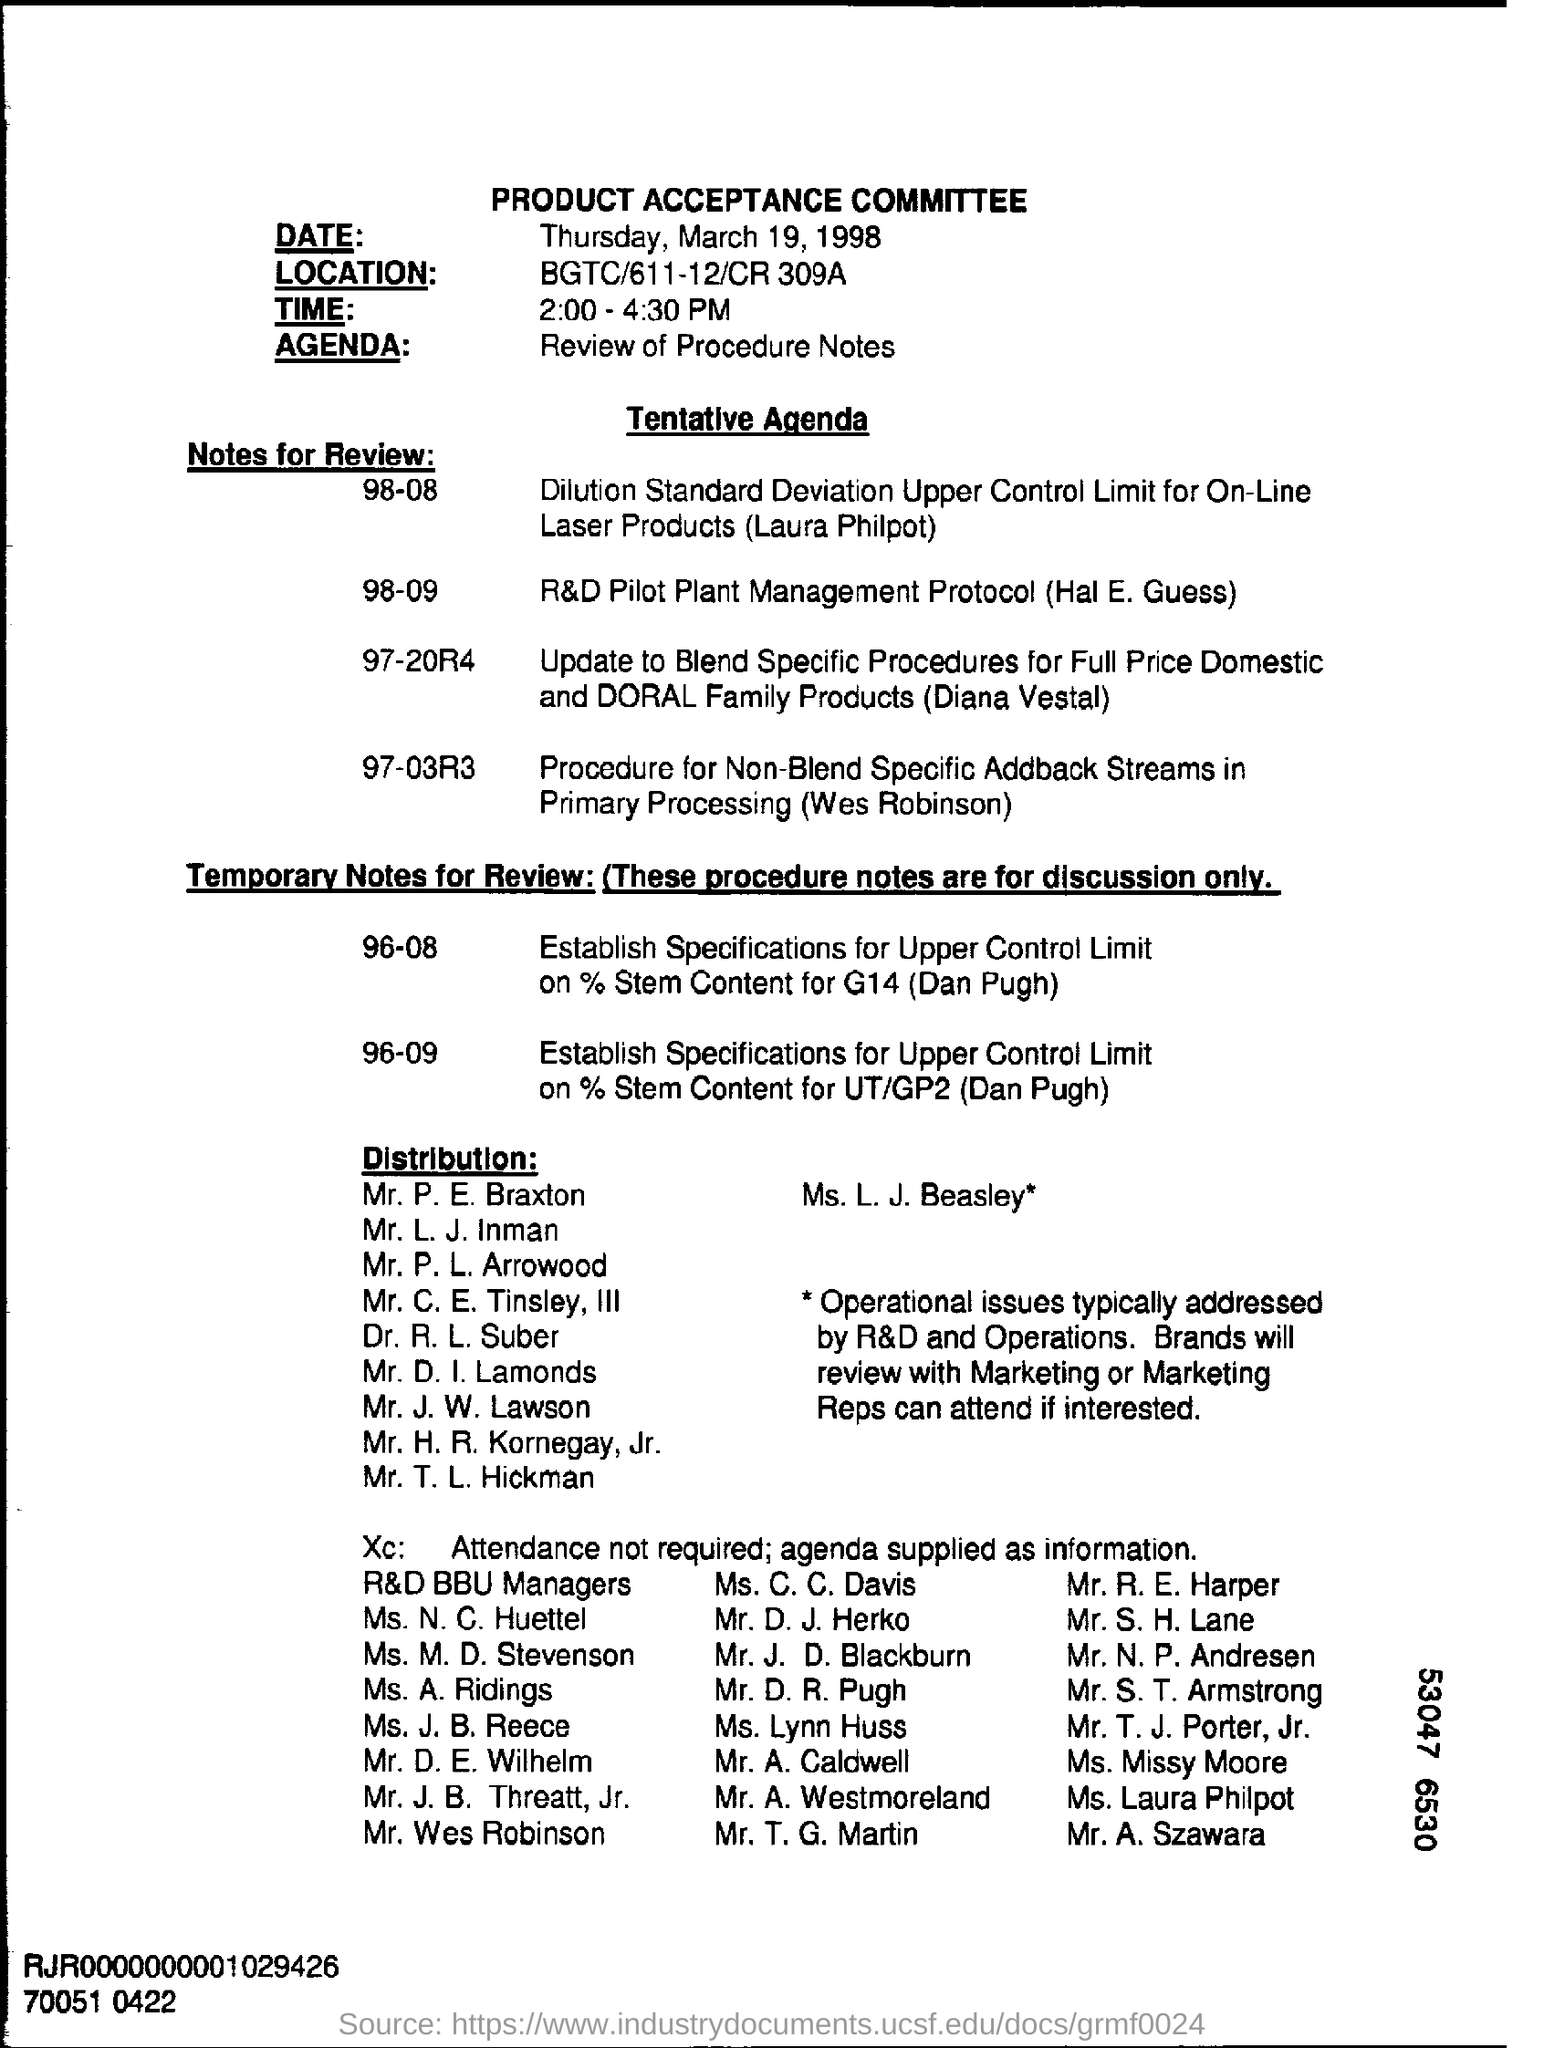Specify some key components in this picture. The location of BGTC/611-12/CR 309A is unknown. The Agenda Field contains the written text 'Review of Procedure Notes.' The Product Acceptance Committee Meeting is scheduled to take place from 2:00 PM to 4:30 PM. The text on the letterhead reads 'PRODUCT ACCEPTANCE COMMITTEE.' The agenda of this meeting is to review the procedure notes. 